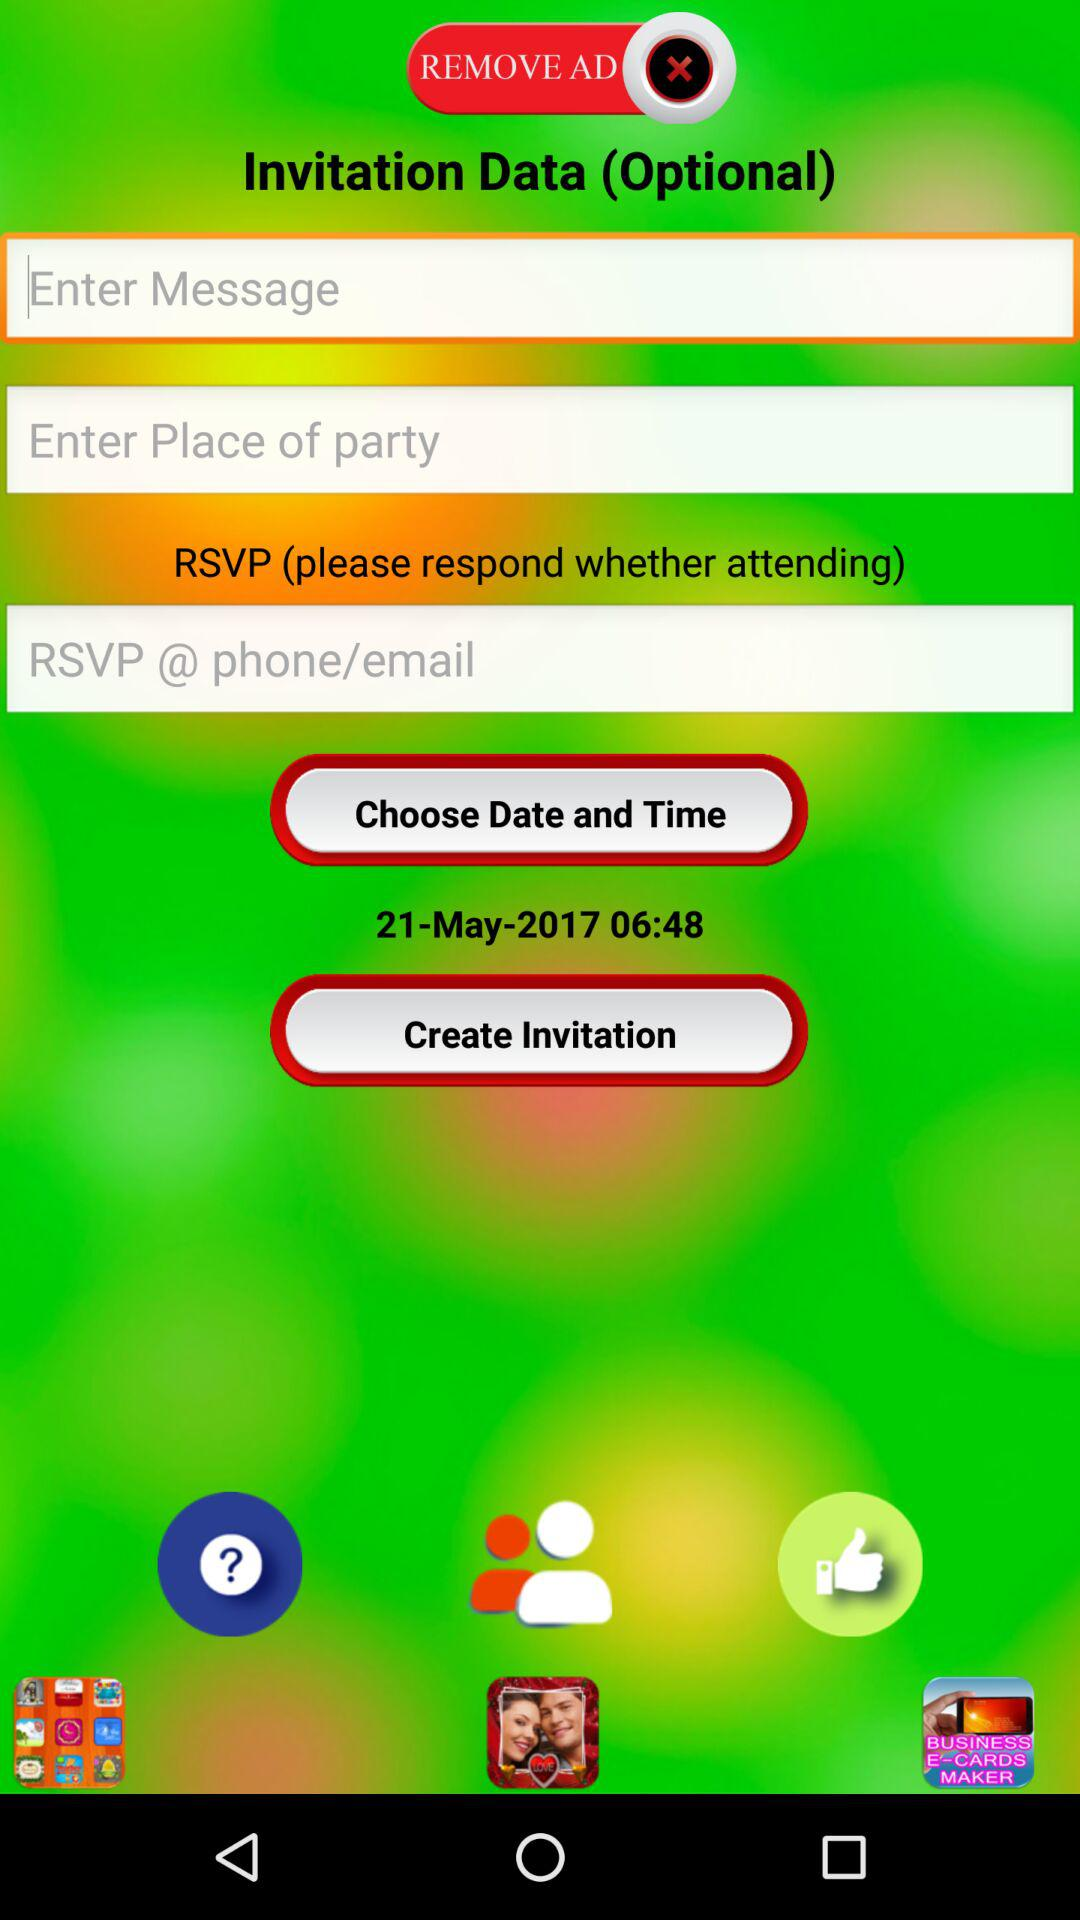Which date and time was chosen? The chosen date was May 21, 2017 and the time was 6:48. 